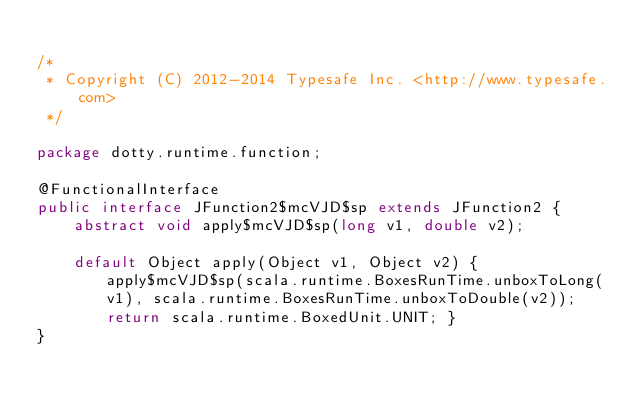Convert code to text. <code><loc_0><loc_0><loc_500><loc_500><_Java_>
/*
 * Copyright (C) 2012-2014 Typesafe Inc. <http://www.typesafe.com>
 */

package dotty.runtime.function;

@FunctionalInterface
public interface JFunction2$mcVJD$sp extends JFunction2 {
    abstract void apply$mcVJD$sp(long v1, double v2);

    default Object apply(Object v1, Object v2) { apply$mcVJD$sp(scala.runtime.BoxesRunTime.unboxToLong(v1), scala.runtime.BoxesRunTime.unboxToDouble(v2)); return scala.runtime.BoxedUnit.UNIT; }
}
</code> 